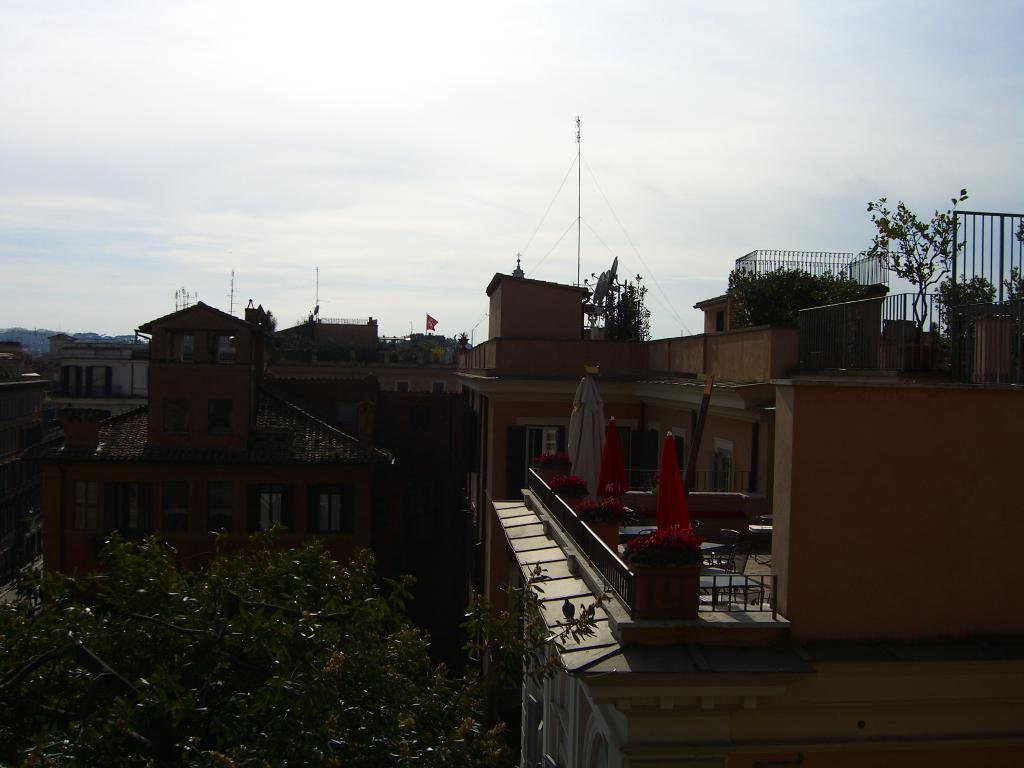What type of structures can be seen in the image? There are buildings in the image. What other elements are present in the image besides buildings? There are plants, a fence, trees, and the sky visible in the image. Can you describe the lighting conditions in the image? The image is a little dark. What year is depicted in the image? There is no specific year depicted in the image; it is a general scene featuring buildings, plants, a fence, trees, and the sky. Can you see a wren perched on the fence in the image? There is no wren present in the image. 